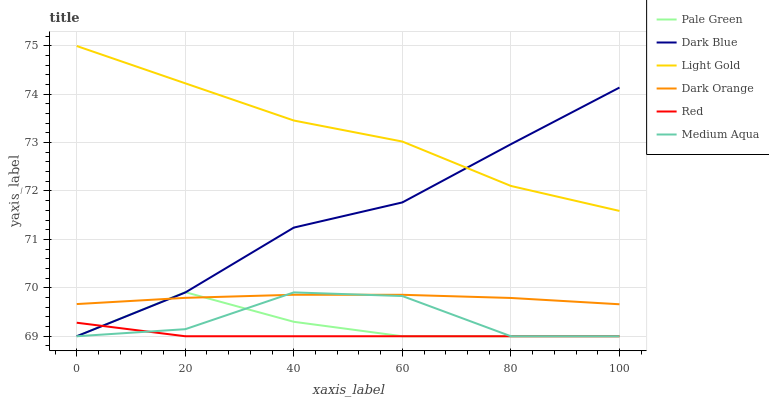Does Red have the minimum area under the curve?
Answer yes or no. Yes. Does Light Gold have the maximum area under the curve?
Answer yes or no. Yes. Does Dark Blue have the minimum area under the curve?
Answer yes or no. No. Does Dark Blue have the maximum area under the curve?
Answer yes or no. No. Is Dark Orange the smoothest?
Answer yes or no. Yes. Is Medium Aqua the roughest?
Answer yes or no. Yes. Is Dark Blue the smoothest?
Answer yes or no. No. Is Dark Blue the roughest?
Answer yes or no. No. Does Dark Blue have the lowest value?
Answer yes or no. Yes. Does Light Gold have the lowest value?
Answer yes or no. No. Does Light Gold have the highest value?
Answer yes or no. Yes. Does Dark Blue have the highest value?
Answer yes or no. No. Is Red less than Dark Orange?
Answer yes or no. Yes. Is Dark Orange greater than Red?
Answer yes or no. Yes. Does Dark Orange intersect Dark Blue?
Answer yes or no. Yes. Is Dark Orange less than Dark Blue?
Answer yes or no. No. Is Dark Orange greater than Dark Blue?
Answer yes or no. No. Does Red intersect Dark Orange?
Answer yes or no. No. 